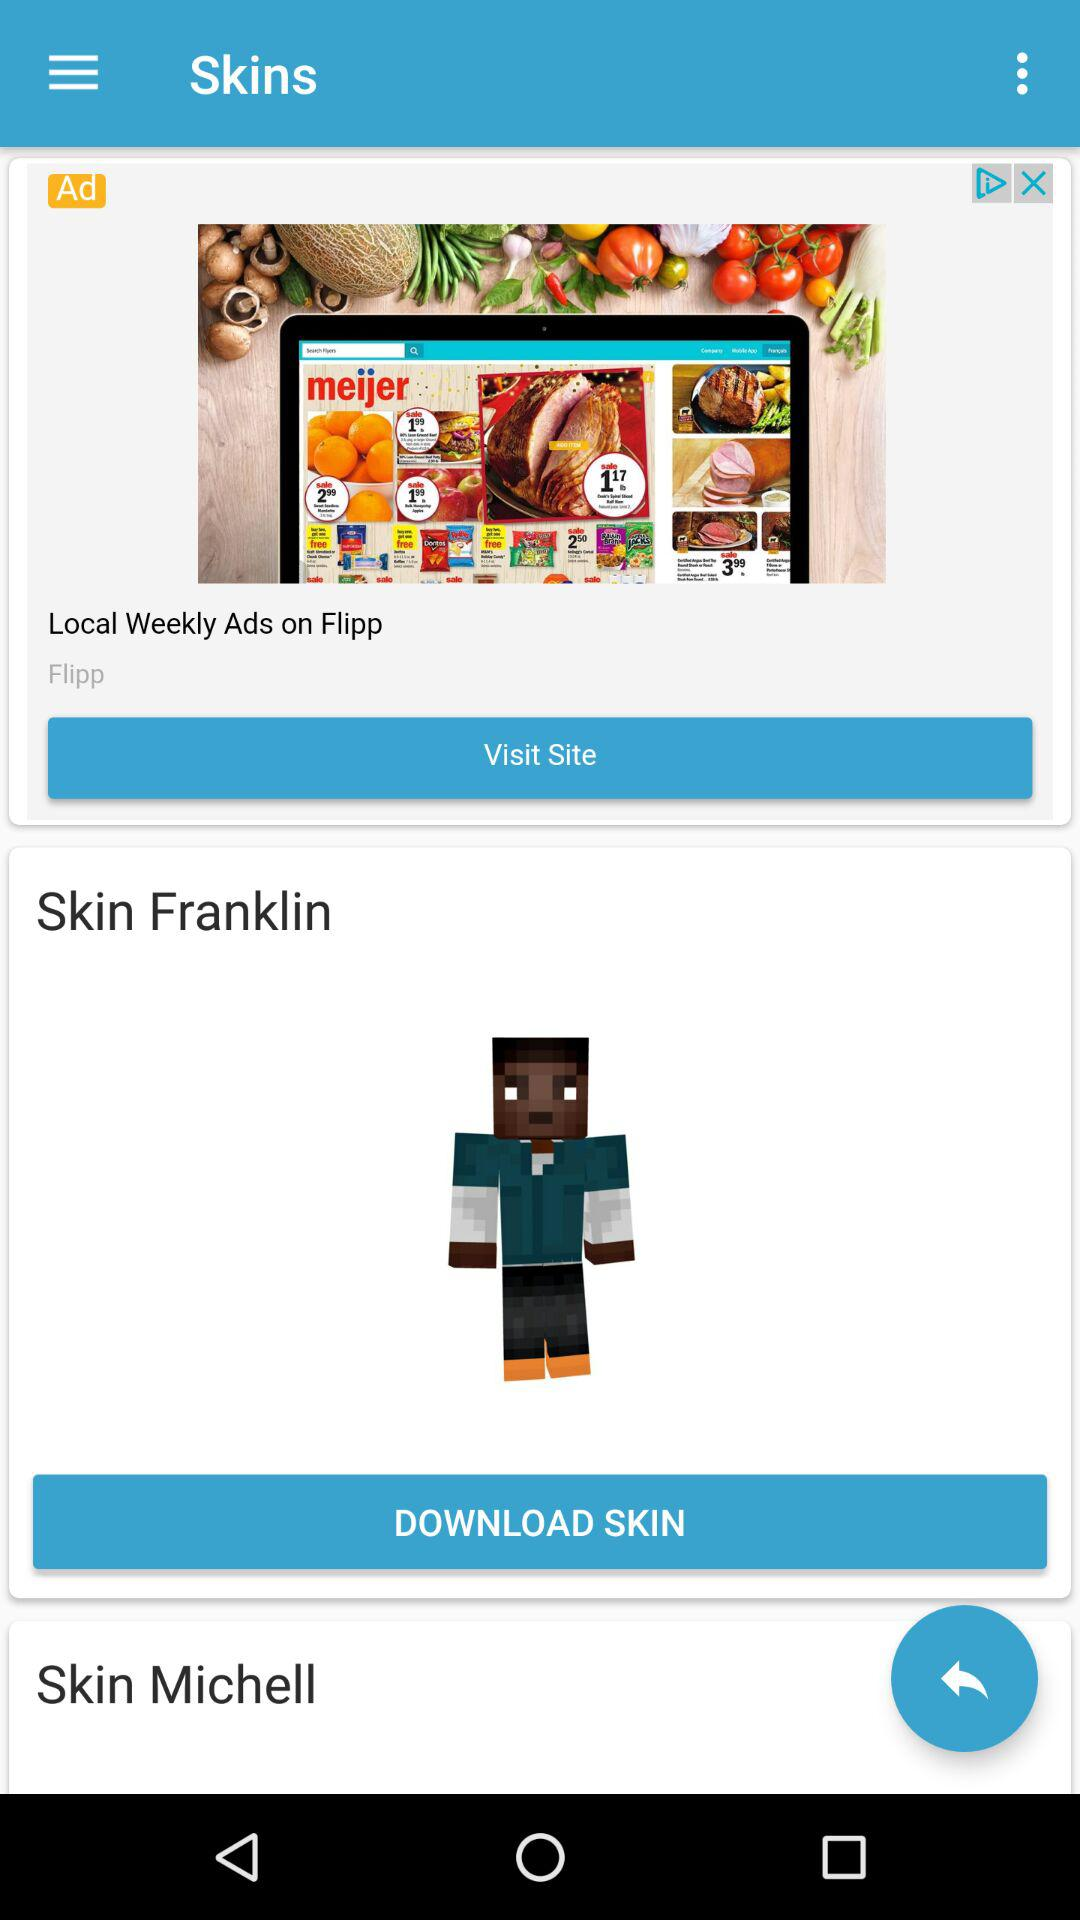How many people have downloaded "Skin Franklin"?
When the provided information is insufficient, respond with <no answer>. <no answer> 